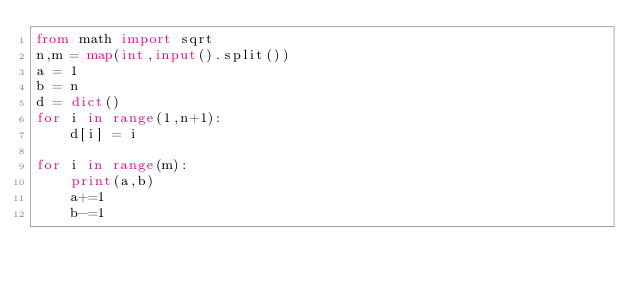<code> <loc_0><loc_0><loc_500><loc_500><_Python_>from math import sqrt
n,m = map(int,input().split())
a = 1
b = n
d = dict()
for i in range(1,n+1):
    d[i] = i

for i in range(m):
    print(a,b)
    a+=1
    b-=1





















</code> 